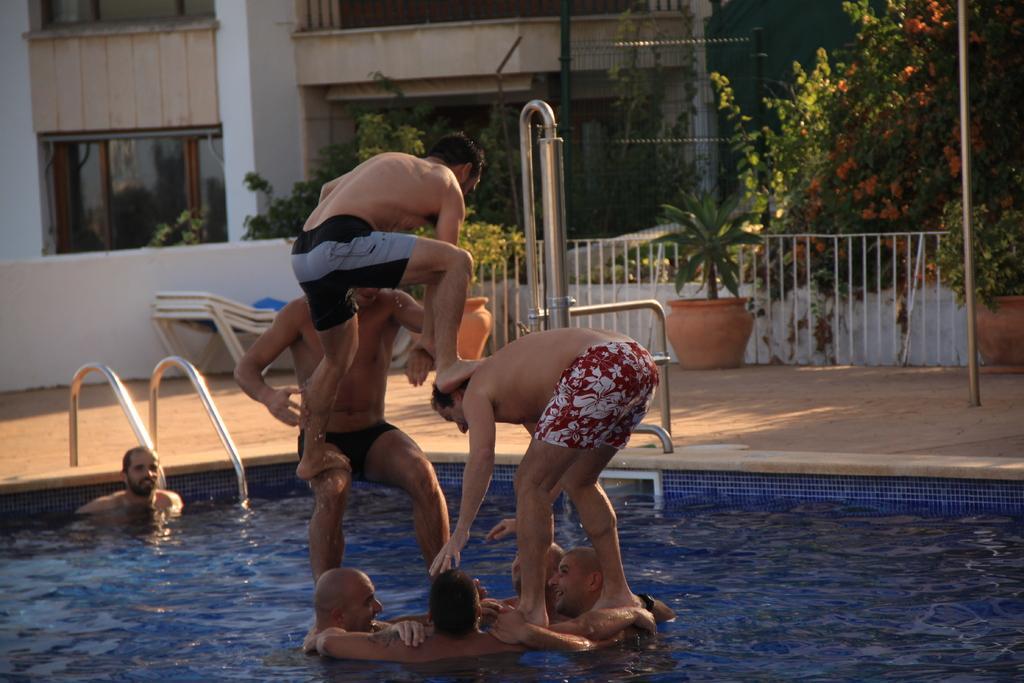How would you summarize this image in a sentence or two? In this picture I can see building and trees and few plants in the pots and I can see few men in the swimming pool and few are standing one on another. 